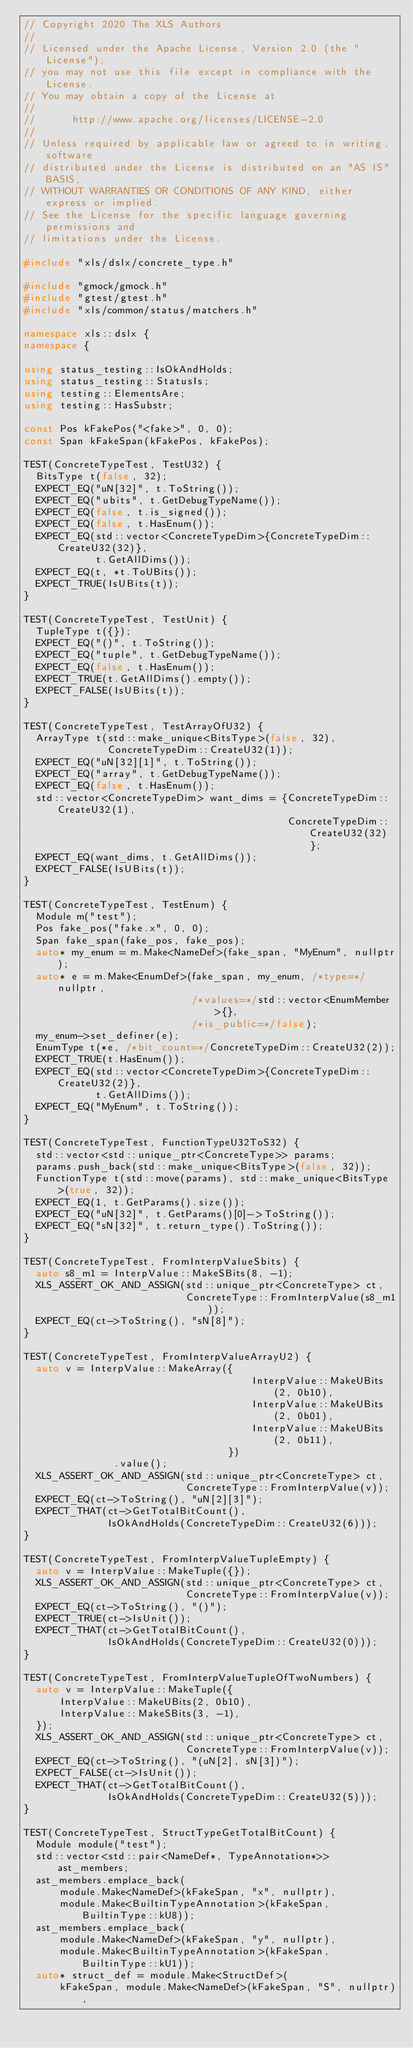Convert code to text. <code><loc_0><loc_0><loc_500><loc_500><_C++_>// Copyright 2020 The XLS Authors
//
// Licensed under the Apache License, Version 2.0 (the "License");
// you may not use this file except in compliance with the License.
// You may obtain a copy of the License at
//
//      http://www.apache.org/licenses/LICENSE-2.0
//
// Unless required by applicable law or agreed to in writing, software
// distributed under the License is distributed on an "AS IS" BASIS,
// WITHOUT WARRANTIES OR CONDITIONS OF ANY KIND, either express or implied.
// See the License for the specific language governing permissions and
// limitations under the License.

#include "xls/dslx/concrete_type.h"

#include "gmock/gmock.h"
#include "gtest/gtest.h"
#include "xls/common/status/matchers.h"

namespace xls::dslx {
namespace {

using status_testing::IsOkAndHolds;
using status_testing::StatusIs;
using testing::ElementsAre;
using testing::HasSubstr;

const Pos kFakePos("<fake>", 0, 0);
const Span kFakeSpan(kFakePos, kFakePos);

TEST(ConcreteTypeTest, TestU32) {
  BitsType t(false, 32);
  EXPECT_EQ("uN[32]", t.ToString());
  EXPECT_EQ("ubits", t.GetDebugTypeName());
  EXPECT_EQ(false, t.is_signed());
  EXPECT_EQ(false, t.HasEnum());
  EXPECT_EQ(std::vector<ConcreteTypeDim>{ConcreteTypeDim::CreateU32(32)},
            t.GetAllDims());
  EXPECT_EQ(t, *t.ToUBits());
  EXPECT_TRUE(IsUBits(t));
}

TEST(ConcreteTypeTest, TestUnit) {
  TupleType t({});
  EXPECT_EQ("()", t.ToString());
  EXPECT_EQ("tuple", t.GetDebugTypeName());
  EXPECT_EQ(false, t.HasEnum());
  EXPECT_TRUE(t.GetAllDims().empty());
  EXPECT_FALSE(IsUBits(t));
}

TEST(ConcreteTypeTest, TestArrayOfU32) {
  ArrayType t(std::make_unique<BitsType>(false, 32),
              ConcreteTypeDim::CreateU32(1));
  EXPECT_EQ("uN[32][1]", t.ToString());
  EXPECT_EQ("array", t.GetDebugTypeName());
  EXPECT_EQ(false, t.HasEnum());
  std::vector<ConcreteTypeDim> want_dims = {ConcreteTypeDim::CreateU32(1),
                                            ConcreteTypeDim::CreateU32(32)};
  EXPECT_EQ(want_dims, t.GetAllDims());
  EXPECT_FALSE(IsUBits(t));
}

TEST(ConcreteTypeTest, TestEnum) {
  Module m("test");
  Pos fake_pos("fake.x", 0, 0);
  Span fake_span(fake_pos, fake_pos);
  auto* my_enum = m.Make<NameDef>(fake_span, "MyEnum", nullptr);
  auto* e = m.Make<EnumDef>(fake_span, my_enum, /*type=*/nullptr,
                            /*values=*/std::vector<EnumMember>{},
                            /*is_public=*/false);
  my_enum->set_definer(e);
  EnumType t(*e, /*bit_count=*/ConcreteTypeDim::CreateU32(2));
  EXPECT_TRUE(t.HasEnum());
  EXPECT_EQ(std::vector<ConcreteTypeDim>{ConcreteTypeDim::CreateU32(2)},
            t.GetAllDims());
  EXPECT_EQ("MyEnum", t.ToString());
}

TEST(ConcreteTypeTest, FunctionTypeU32ToS32) {
  std::vector<std::unique_ptr<ConcreteType>> params;
  params.push_back(std::make_unique<BitsType>(false, 32));
  FunctionType t(std::move(params), std::make_unique<BitsType>(true, 32));
  EXPECT_EQ(1, t.GetParams().size());
  EXPECT_EQ("uN[32]", t.GetParams()[0]->ToString());
  EXPECT_EQ("sN[32]", t.return_type().ToString());
}

TEST(ConcreteTypeTest, FromInterpValueSbits) {
  auto s8_m1 = InterpValue::MakeSBits(8, -1);
  XLS_ASSERT_OK_AND_ASSIGN(std::unique_ptr<ConcreteType> ct,
                           ConcreteType::FromInterpValue(s8_m1));
  EXPECT_EQ(ct->ToString(), "sN[8]");
}

TEST(ConcreteTypeTest, FromInterpValueArrayU2) {
  auto v = InterpValue::MakeArray({
                                      InterpValue::MakeUBits(2, 0b10),
                                      InterpValue::MakeUBits(2, 0b01),
                                      InterpValue::MakeUBits(2, 0b11),
                                  })
               .value();
  XLS_ASSERT_OK_AND_ASSIGN(std::unique_ptr<ConcreteType> ct,
                           ConcreteType::FromInterpValue(v));
  EXPECT_EQ(ct->ToString(), "uN[2][3]");
  EXPECT_THAT(ct->GetTotalBitCount(),
              IsOkAndHolds(ConcreteTypeDim::CreateU32(6)));
}

TEST(ConcreteTypeTest, FromInterpValueTupleEmpty) {
  auto v = InterpValue::MakeTuple({});
  XLS_ASSERT_OK_AND_ASSIGN(std::unique_ptr<ConcreteType> ct,
                           ConcreteType::FromInterpValue(v));
  EXPECT_EQ(ct->ToString(), "()");
  EXPECT_TRUE(ct->IsUnit());
  EXPECT_THAT(ct->GetTotalBitCount(),
              IsOkAndHolds(ConcreteTypeDim::CreateU32(0)));
}

TEST(ConcreteTypeTest, FromInterpValueTupleOfTwoNumbers) {
  auto v = InterpValue::MakeTuple({
      InterpValue::MakeUBits(2, 0b10),
      InterpValue::MakeSBits(3, -1),
  });
  XLS_ASSERT_OK_AND_ASSIGN(std::unique_ptr<ConcreteType> ct,
                           ConcreteType::FromInterpValue(v));
  EXPECT_EQ(ct->ToString(), "(uN[2], sN[3])");
  EXPECT_FALSE(ct->IsUnit());
  EXPECT_THAT(ct->GetTotalBitCount(),
              IsOkAndHolds(ConcreteTypeDim::CreateU32(5)));
}

TEST(ConcreteTypeTest, StructTypeGetTotalBitCount) {
  Module module("test");
  std::vector<std::pair<NameDef*, TypeAnnotation*>> ast_members;
  ast_members.emplace_back(
      module.Make<NameDef>(kFakeSpan, "x", nullptr),
      module.Make<BuiltinTypeAnnotation>(kFakeSpan, BuiltinType::kU8));
  ast_members.emplace_back(
      module.Make<NameDef>(kFakeSpan, "y", nullptr),
      module.Make<BuiltinTypeAnnotation>(kFakeSpan, BuiltinType::kU1));
  auto* struct_def = module.Make<StructDef>(
      kFakeSpan, module.Make<NameDef>(kFakeSpan, "S", nullptr),</code> 